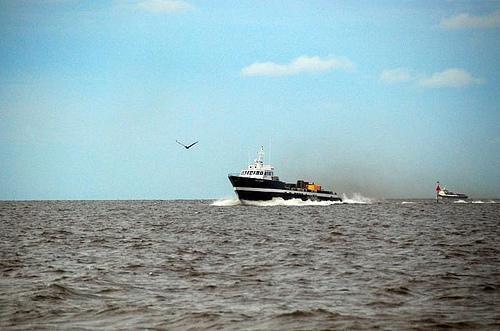How many boats have yellow crates?
Give a very brief answer. 1. How many boats are there?
Give a very brief answer. 2. How many birds are there?
Give a very brief answer. 2. 